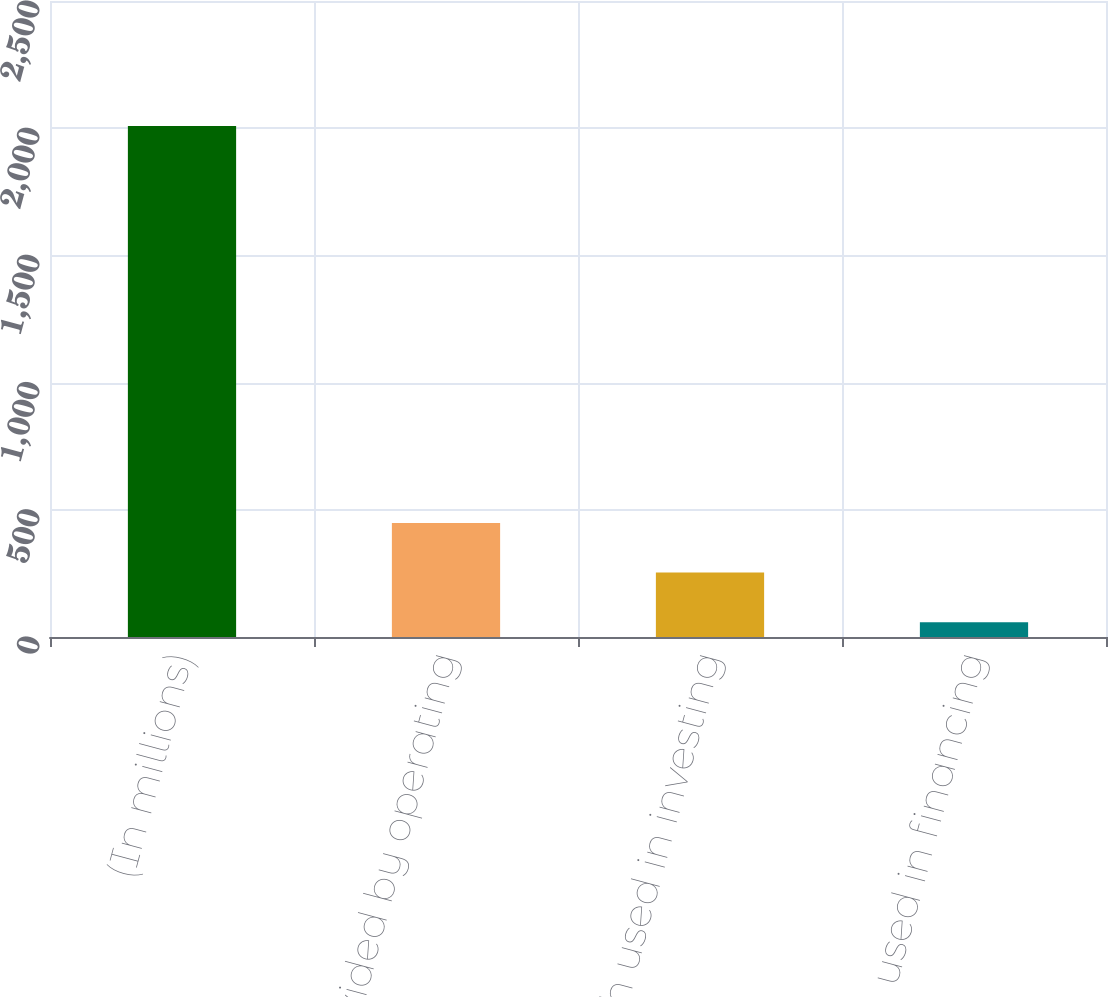Convert chart to OTSL. <chart><loc_0><loc_0><loc_500><loc_500><bar_chart><fcel>(In millions)<fcel>Net cash provided by operating<fcel>Net cash used in investing<fcel>Net cash used in financing<nl><fcel>2009<fcel>448.44<fcel>253.37<fcel>58.3<nl></chart> 